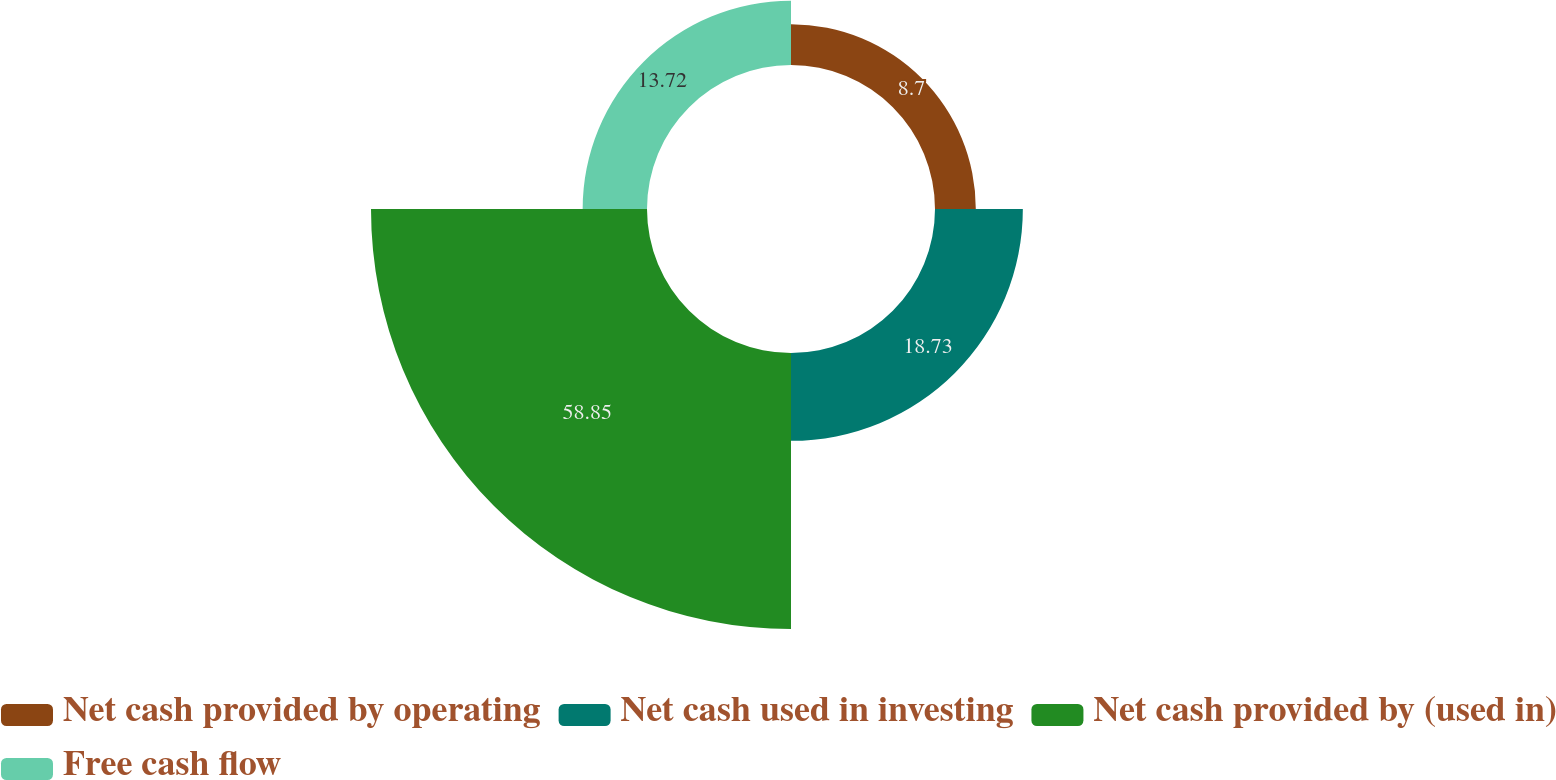<chart> <loc_0><loc_0><loc_500><loc_500><pie_chart><fcel>Net cash provided by operating<fcel>Net cash used in investing<fcel>Net cash provided by (used in)<fcel>Free cash flow<nl><fcel>8.7%<fcel>18.73%<fcel>58.85%<fcel>13.72%<nl></chart> 